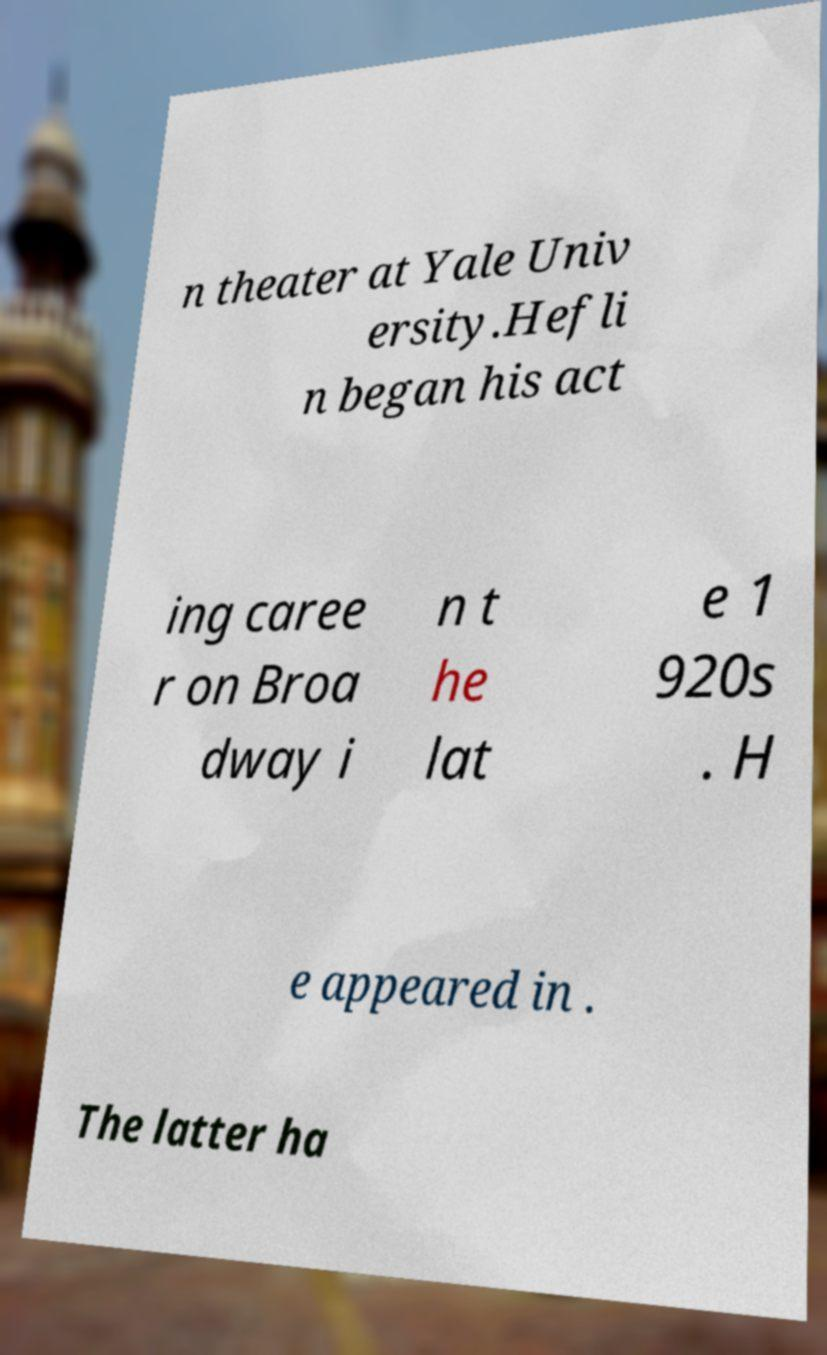What messages or text are displayed in this image? I need them in a readable, typed format. n theater at Yale Univ ersity.Hefli n began his act ing caree r on Broa dway i n t he lat e 1 920s . H e appeared in . The latter ha 